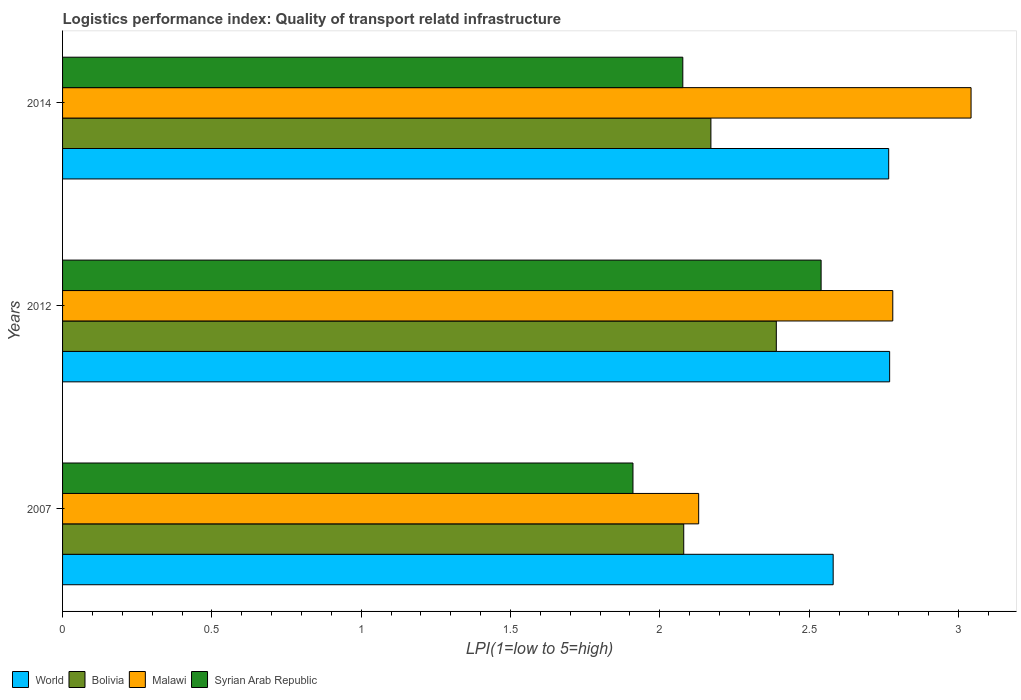How many groups of bars are there?
Your answer should be compact. 3. Are the number of bars per tick equal to the number of legend labels?
Keep it short and to the point. Yes. How many bars are there on the 2nd tick from the bottom?
Provide a short and direct response. 4. In how many cases, is the number of bars for a given year not equal to the number of legend labels?
Give a very brief answer. 0. What is the logistics performance index in World in 2014?
Your answer should be compact. 2.77. Across all years, what is the maximum logistics performance index in World?
Offer a terse response. 2.77. Across all years, what is the minimum logistics performance index in Bolivia?
Your answer should be very brief. 2.08. In which year was the logistics performance index in Bolivia minimum?
Make the answer very short. 2007. What is the total logistics performance index in World in the graph?
Ensure brevity in your answer.  8.12. What is the difference between the logistics performance index in Malawi in 2007 and that in 2014?
Your answer should be compact. -0.91. What is the difference between the logistics performance index in Syrian Arab Republic in 2014 and the logistics performance index in Bolivia in 2007?
Your response must be concise. -0. What is the average logistics performance index in Malawi per year?
Your answer should be very brief. 2.65. In the year 2012, what is the difference between the logistics performance index in World and logistics performance index in Malawi?
Make the answer very short. -0.01. In how many years, is the logistics performance index in Syrian Arab Republic greater than 0.6 ?
Make the answer very short. 3. What is the ratio of the logistics performance index in Bolivia in 2007 to that in 2014?
Offer a very short reply. 0.96. What is the difference between the highest and the second highest logistics performance index in Malawi?
Your answer should be compact. 0.26. What is the difference between the highest and the lowest logistics performance index in Bolivia?
Your answer should be very brief. 0.31. Is the sum of the logistics performance index in Malawi in 2007 and 2012 greater than the maximum logistics performance index in World across all years?
Provide a succinct answer. Yes. Is it the case that in every year, the sum of the logistics performance index in Bolivia and logistics performance index in Malawi is greater than the sum of logistics performance index in World and logistics performance index in Syrian Arab Republic?
Your answer should be compact. No. What does the 4th bar from the top in 2007 represents?
Make the answer very short. World. What does the 4th bar from the bottom in 2012 represents?
Offer a very short reply. Syrian Arab Republic. Is it the case that in every year, the sum of the logistics performance index in Syrian Arab Republic and logistics performance index in World is greater than the logistics performance index in Bolivia?
Ensure brevity in your answer.  Yes. Are all the bars in the graph horizontal?
Your response must be concise. Yes. Are the values on the major ticks of X-axis written in scientific E-notation?
Your answer should be compact. No. Where does the legend appear in the graph?
Provide a succinct answer. Bottom left. How are the legend labels stacked?
Offer a very short reply. Horizontal. What is the title of the graph?
Provide a short and direct response. Logistics performance index: Quality of transport relatd infrastructure. Does "Pacific island small states" appear as one of the legend labels in the graph?
Your answer should be compact. No. What is the label or title of the X-axis?
Keep it short and to the point. LPI(1=low to 5=high). What is the label or title of the Y-axis?
Offer a terse response. Years. What is the LPI(1=low to 5=high) of World in 2007?
Ensure brevity in your answer.  2.58. What is the LPI(1=low to 5=high) in Bolivia in 2007?
Offer a terse response. 2.08. What is the LPI(1=low to 5=high) of Malawi in 2007?
Provide a succinct answer. 2.13. What is the LPI(1=low to 5=high) of Syrian Arab Republic in 2007?
Keep it short and to the point. 1.91. What is the LPI(1=low to 5=high) in World in 2012?
Your response must be concise. 2.77. What is the LPI(1=low to 5=high) of Bolivia in 2012?
Your answer should be compact. 2.39. What is the LPI(1=low to 5=high) of Malawi in 2012?
Give a very brief answer. 2.78. What is the LPI(1=low to 5=high) of Syrian Arab Republic in 2012?
Your answer should be very brief. 2.54. What is the LPI(1=low to 5=high) in World in 2014?
Your answer should be compact. 2.77. What is the LPI(1=low to 5=high) of Bolivia in 2014?
Provide a succinct answer. 2.17. What is the LPI(1=low to 5=high) in Malawi in 2014?
Your response must be concise. 3.04. What is the LPI(1=low to 5=high) of Syrian Arab Republic in 2014?
Provide a succinct answer. 2.08. Across all years, what is the maximum LPI(1=low to 5=high) in World?
Your response must be concise. 2.77. Across all years, what is the maximum LPI(1=low to 5=high) in Bolivia?
Keep it short and to the point. 2.39. Across all years, what is the maximum LPI(1=low to 5=high) of Malawi?
Offer a terse response. 3.04. Across all years, what is the maximum LPI(1=low to 5=high) in Syrian Arab Republic?
Provide a short and direct response. 2.54. Across all years, what is the minimum LPI(1=low to 5=high) of World?
Your response must be concise. 2.58. Across all years, what is the minimum LPI(1=low to 5=high) of Bolivia?
Offer a terse response. 2.08. Across all years, what is the minimum LPI(1=low to 5=high) in Malawi?
Offer a very short reply. 2.13. Across all years, what is the minimum LPI(1=low to 5=high) of Syrian Arab Republic?
Keep it short and to the point. 1.91. What is the total LPI(1=low to 5=high) of World in the graph?
Offer a very short reply. 8.12. What is the total LPI(1=low to 5=high) of Bolivia in the graph?
Offer a very short reply. 6.64. What is the total LPI(1=low to 5=high) in Malawi in the graph?
Your answer should be very brief. 7.95. What is the total LPI(1=low to 5=high) of Syrian Arab Republic in the graph?
Your answer should be very brief. 6.53. What is the difference between the LPI(1=low to 5=high) of World in 2007 and that in 2012?
Offer a very short reply. -0.19. What is the difference between the LPI(1=low to 5=high) of Bolivia in 2007 and that in 2012?
Offer a terse response. -0.31. What is the difference between the LPI(1=low to 5=high) in Malawi in 2007 and that in 2012?
Your response must be concise. -0.65. What is the difference between the LPI(1=low to 5=high) of Syrian Arab Republic in 2007 and that in 2012?
Offer a very short reply. -0.63. What is the difference between the LPI(1=low to 5=high) of World in 2007 and that in 2014?
Your answer should be compact. -0.19. What is the difference between the LPI(1=low to 5=high) of Bolivia in 2007 and that in 2014?
Make the answer very short. -0.09. What is the difference between the LPI(1=low to 5=high) of Malawi in 2007 and that in 2014?
Offer a terse response. -0.91. What is the difference between the LPI(1=low to 5=high) in Syrian Arab Republic in 2007 and that in 2014?
Make the answer very short. -0.17. What is the difference between the LPI(1=low to 5=high) in World in 2012 and that in 2014?
Your answer should be compact. 0. What is the difference between the LPI(1=low to 5=high) of Bolivia in 2012 and that in 2014?
Your answer should be very brief. 0.22. What is the difference between the LPI(1=low to 5=high) in Malawi in 2012 and that in 2014?
Provide a short and direct response. -0.26. What is the difference between the LPI(1=low to 5=high) in Syrian Arab Republic in 2012 and that in 2014?
Your answer should be compact. 0.46. What is the difference between the LPI(1=low to 5=high) in World in 2007 and the LPI(1=low to 5=high) in Bolivia in 2012?
Give a very brief answer. 0.19. What is the difference between the LPI(1=low to 5=high) of World in 2007 and the LPI(1=low to 5=high) of Malawi in 2012?
Make the answer very short. -0.2. What is the difference between the LPI(1=low to 5=high) of World in 2007 and the LPI(1=low to 5=high) of Syrian Arab Republic in 2012?
Provide a short and direct response. 0.04. What is the difference between the LPI(1=low to 5=high) in Bolivia in 2007 and the LPI(1=low to 5=high) in Syrian Arab Republic in 2012?
Your answer should be compact. -0.46. What is the difference between the LPI(1=low to 5=high) of Malawi in 2007 and the LPI(1=low to 5=high) of Syrian Arab Republic in 2012?
Your response must be concise. -0.41. What is the difference between the LPI(1=low to 5=high) in World in 2007 and the LPI(1=low to 5=high) in Bolivia in 2014?
Your answer should be very brief. 0.41. What is the difference between the LPI(1=low to 5=high) of World in 2007 and the LPI(1=low to 5=high) of Malawi in 2014?
Your response must be concise. -0.46. What is the difference between the LPI(1=low to 5=high) in World in 2007 and the LPI(1=low to 5=high) in Syrian Arab Republic in 2014?
Provide a succinct answer. 0.5. What is the difference between the LPI(1=low to 5=high) in Bolivia in 2007 and the LPI(1=low to 5=high) in Malawi in 2014?
Give a very brief answer. -0.96. What is the difference between the LPI(1=low to 5=high) in Bolivia in 2007 and the LPI(1=low to 5=high) in Syrian Arab Republic in 2014?
Your answer should be very brief. 0. What is the difference between the LPI(1=low to 5=high) of Malawi in 2007 and the LPI(1=low to 5=high) of Syrian Arab Republic in 2014?
Your response must be concise. 0.05. What is the difference between the LPI(1=low to 5=high) of World in 2012 and the LPI(1=low to 5=high) of Bolivia in 2014?
Keep it short and to the point. 0.6. What is the difference between the LPI(1=low to 5=high) in World in 2012 and the LPI(1=low to 5=high) in Malawi in 2014?
Give a very brief answer. -0.27. What is the difference between the LPI(1=low to 5=high) of World in 2012 and the LPI(1=low to 5=high) of Syrian Arab Republic in 2014?
Offer a terse response. 0.69. What is the difference between the LPI(1=low to 5=high) of Bolivia in 2012 and the LPI(1=low to 5=high) of Malawi in 2014?
Keep it short and to the point. -0.65. What is the difference between the LPI(1=low to 5=high) in Bolivia in 2012 and the LPI(1=low to 5=high) in Syrian Arab Republic in 2014?
Give a very brief answer. 0.31. What is the difference between the LPI(1=low to 5=high) of Malawi in 2012 and the LPI(1=low to 5=high) of Syrian Arab Republic in 2014?
Your answer should be compact. 0.7. What is the average LPI(1=low to 5=high) in World per year?
Keep it short and to the point. 2.71. What is the average LPI(1=low to 5=high) in Bolivia per year?
Offer a very short reply. 2.21. What is the average LPI(1=low to 5=high) in Malawi per year?
Make the answer very short. 2.65. What is the average LPI(1=low to 5=high) in Syrian Arab Republic per year?
Provide a short and direct response. 2.18. In the year 2007, what is the difference between the LPI(1=low to 5=high) of World and LPI(1=low to 5=high) of Bolivia?
Your answer should be compact. 0.5. In the year 2007, what is the difference between the LPI(1=low to 5=high) in World and LPI(1=low to 5=high) in Malawi?
Ensure brevity in your answer.  0.45. In the year 2007, what is the difference between the LPI(1=low to 5=high) of World and LPI(1=low to 5=high) of Syrian Arab Republic?
Provide a succinct answer. 0.67. In the year 2007, what is the difference between the LPI(1=low to 5=high) in Bolivia and LPI(1=low to 5=high) in Malawi?
Provide a short and direct response. -0.05. In the year 2007, what is the difference between the LPI(1=low to 5=high) in Bolivia and LPI(1=low to 5=high) in Syrian Arab Republic?
Your answer should be very brief. 0.17. In the year 2007, what is the difference between the LPI(1=low to 5=high) of Malawi and LPI(1=low to 5=high) of Syrian Arab Republic?
Offer a very short reply. 0.22. In the year 2012, what is the difference between the LPI(1=low to 5=high) in World and LPI(1=low to 5=high) in Bolivia?
Your response must be concise. 0.38. In the year 2012, what is the difference between the LPI(1=low to 5=high) in World and LPI(1=low to 5=high) in Malawi?
Provide a succinct answer. -0.01. In the year 2012, what is the difference between the LPI(1=low to 5=high) of World and LPI(1=low to 5=high) of Syrian Arab Republic?
Keep it short and to the point. 0.23. In the year 2012, what is the difference between the LPI(1=low to 5=high) in Bolivia and LPI(1=low to 5=high) in Malawi?
Keep it short and to the point. -0.39. In the year 2012, what is the difference between the LPI(1=low to 5=high) of Bolivia and LPI(1=low to 5=high) of Syrian Arab Republic?
Provide a short and direct response. -0.15. In the year 2012, what is the difference between the LPI(1=low to 5=high) in Malawi and LPI(1=low to 5=high) in Syrian Arab Republic?
Your answer should be compact. 0.24. In the year 2014, what is the difference between the LPI(1=low to 5=high) of World and LPI(1=low to 5=high) of Bolivia?
Provide a short and direct response. 0.6. In the year 2014, what is the difference between the LPI(1=low to 5=high) of World and LPI(1=low to 5=high) of Malawi?
Your response must be concise. -0.28. In the year 2014, what is the difference between the LPI(1=low to 5=high) of World and LPI(1=low to 5=high) of Syrian Arab Republic?
Your answer should be very brief. 0.69. In the year 2014, what is the difference between the LPI(1=low to 5=high) in Bolivia and LPI(1=low to 5=high) in Malawi?
Your response must be concise. -0.87. In the year 2014, what is the difference between the LPI(1=low to 5=high) in Bolivia and LPI(1=low to 5=high) in Syrian Arab Republic?
Provide a succinct answer. 0.09. In the year 2014, what is the difference between the LPI(1=low to 5=high) in Malawi and LPI(1=low to 5=high) in Syrian Arab Republic?
Make the answer very short. 0.97. What is the ratio of the LPI(1=low to 5=high) of World in 2007 to that in 2012?
Your response must be concise. 0.93. What is the ratio of the LPI(1=low to 5=high) in Bolivia in 2007 to that in 2012?
Your answer should be very brief. 0.87. What is the ratio of the LPI(1=low to 5=high) of Malawi in 2007 to that in 2012?
Provide a succinct answer. 0.77. What is the ratio of the LPI(1=low to 5=high) in Syrian Arab Republic in 2007 to that in 2012?
Offer a very short reply. 0.75. What is the ratio of the LPI(1=low to 5=high) in World in 2007 to that in 2014?
Ensure brevity in your answer.  0.93. What is the ratio of the LPI(1=low to 5=high) of Bolivia in 2007 to that in 2014?
Keep it short and to the point. 0.96. What is the ratio of the LPI(1=low to 5=high) in Malawi in 2007 to that in 2014?
Your response must be concise. 0.7. What is the ratio of the LPI(1=low to 5=high) in Syrian Arab Republic in 2007 to that in 2014?
Make the answer very short. 0.92. What is the ratio of the LPI(1=low to 5=high) of Bolivia in 2012 to that in 2014?
Provide a succinct answer. 1.1. What is the ratio of the LPI(1=low to 5=high) of Malawi in 2012 to that in 2014?
Your answer should be very brief. 0.91. What is the ratio of the LPI(1=low to 5=high) of Syrian Arab Republic in 2012 to that in 2014?
Offer a very short reply. 1.22. What is the difference between the highest and the second highest LPI(1=low to 5=high) of World?
Your answer should be very brief. 0. What is the difference between the highest and the second highest LPI(1=low to 5=high) in Bolivia?
Your answer should be compact. 0.22. What is the difference between the highest and the second highest LPI(1=low to 5=high) of Malawi?
Your answer should be very brief. 0.26. What is the difference between the highest and the second highest LPI(1=low to 5=high) in Syrian Arab Republic?
Your answer should be very brief. 0.46. What is the difference between the highest and the lowest LPI(1=low to 5=high) of World?
Offer a very short reply. 0.19. What is the difference between the highest and the lowest LPI(1=low to 5=high) of Bolivia?
Keep it short and to the point. 0.31. What is the difference between the highest and the lowest LPI(1=low to 5=high) of Malawi?
Offer a very short reply. 0.91. What is the difference between the highest and the lowest LPI(1=low to 5=high) in Syrian Arab Republic?
Offer a terse response. 0.63. 